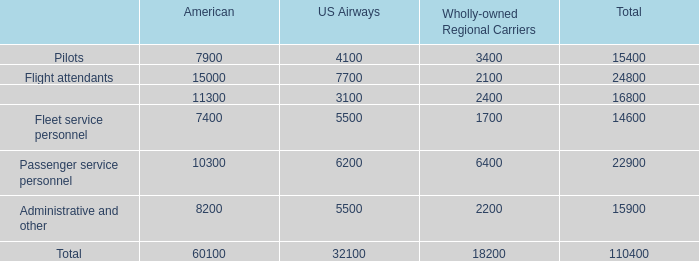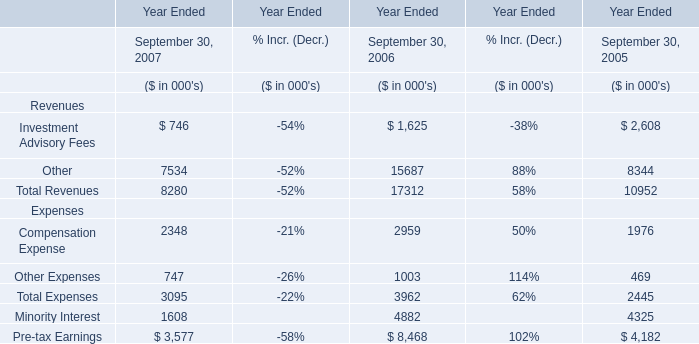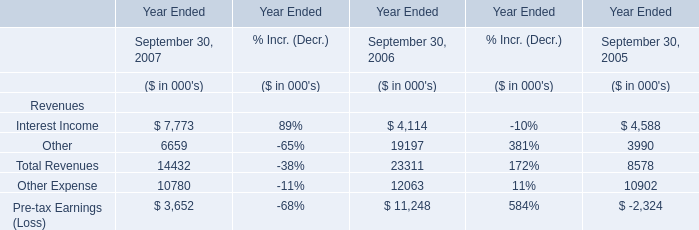What was the average value of Interest Income, Other, Other Expense in 2006? (in thousand) 
Computations: (((4114 + 19197) + 12063) / 3)
Answer: 11791.33333. 